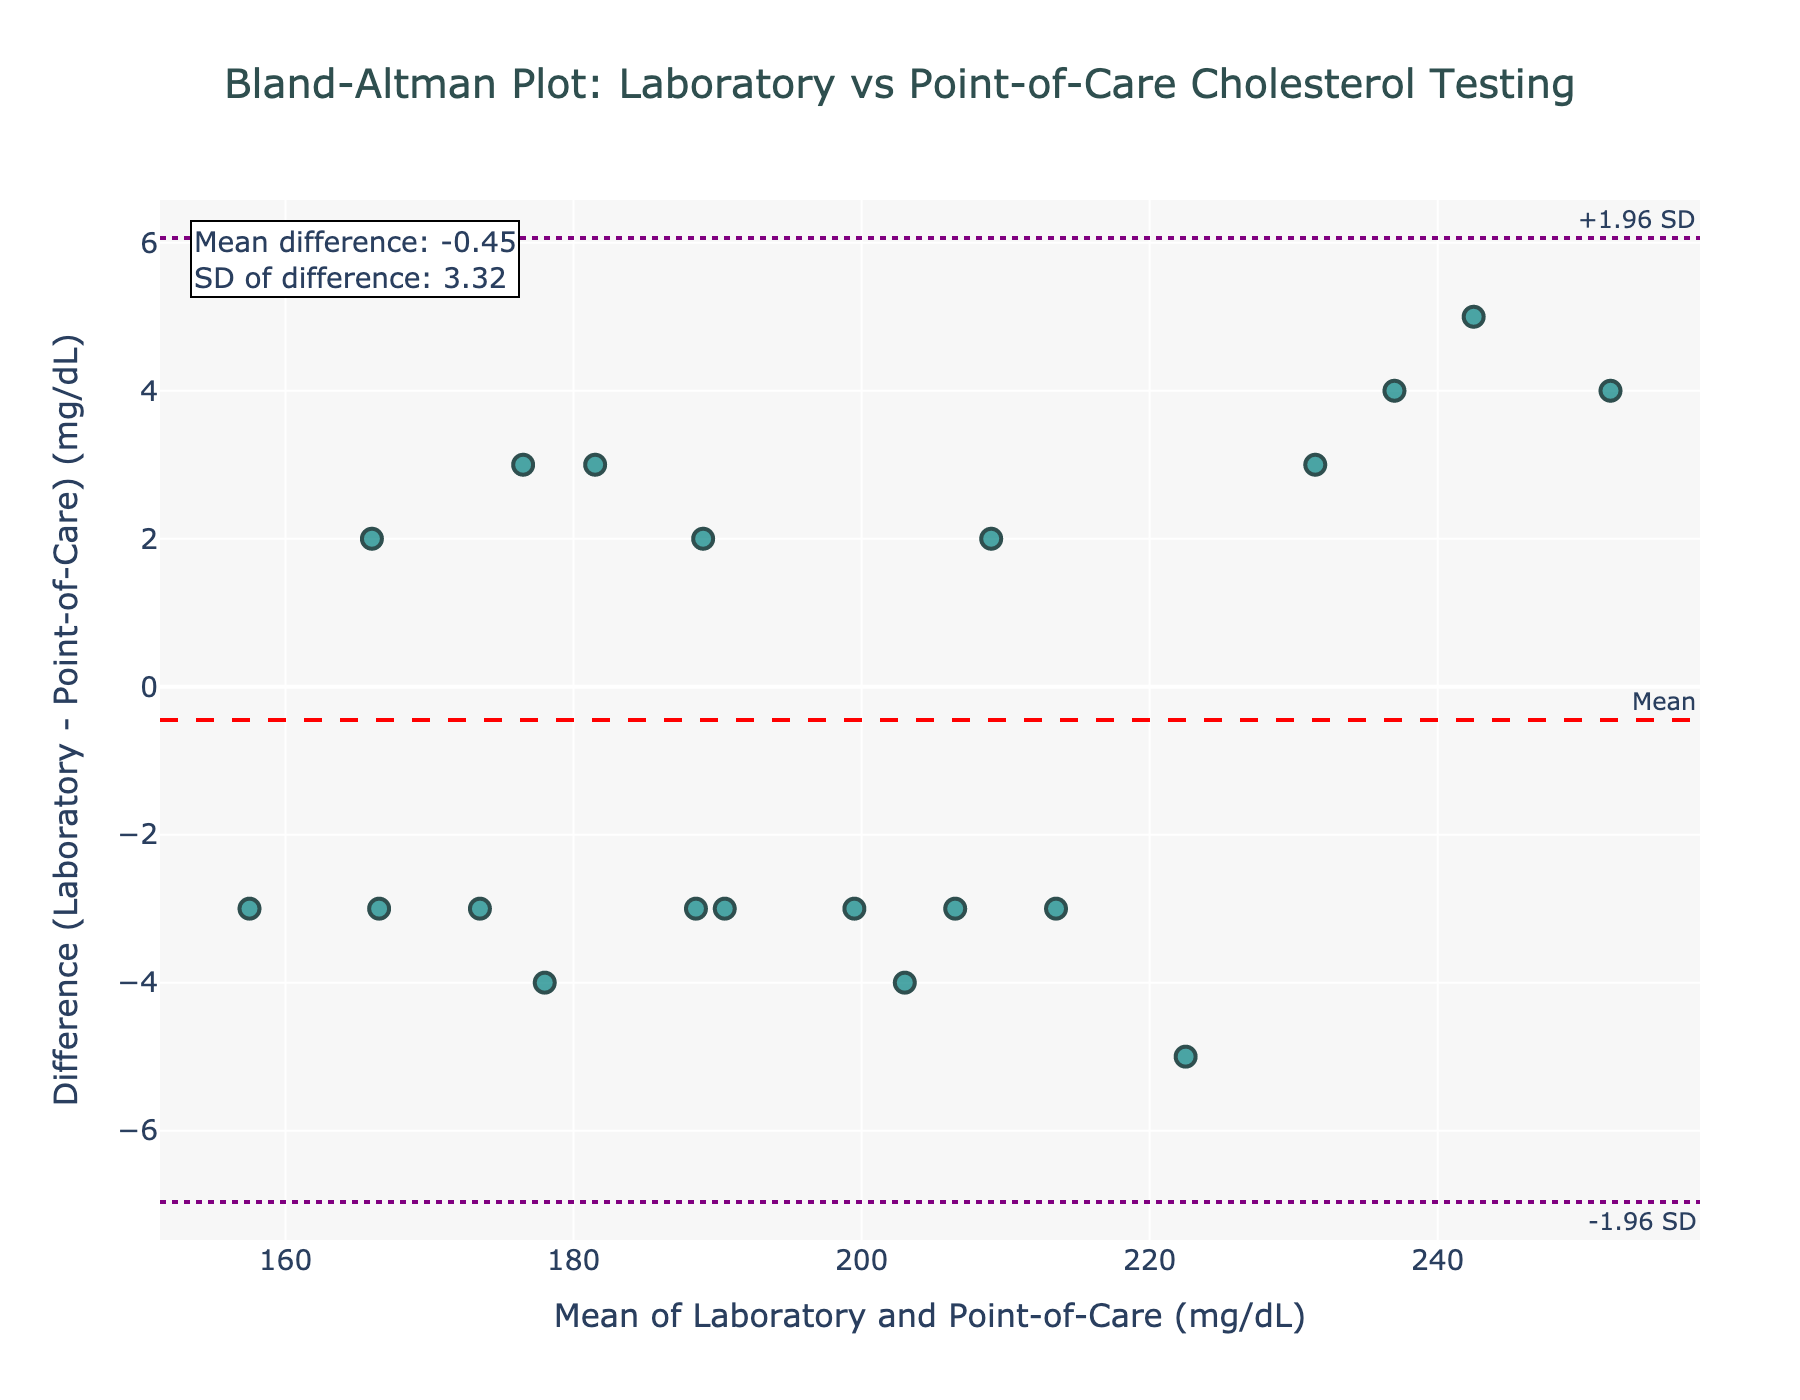How many data points are plotted on the figure? The data table provides 20 measurements (one per patient), and the plot should reflect all of these. Counting the plotted points confirms there are indeed 20 points.
Answer: 20 What is the title of the plot? The title is displayed at the top of the plot, and it reads: "Bland-Altman Plot: Laboratory vs Point-of-Care Cholesterol Testing".
Answer: Bland-Altman Plot: Laboratory vs Point-of-Care Cholesterol Testing What are the units used for the x-axis? The x-axis represents the mean of Laboratory and Point-of-Care values and is labeled, indicating the units as mg/dL (milligrams per deciliter).
Answer: mg/dL What is the mean difference value shown on the figure? The mean difference is the horizontal dashed red line annotated with "Mean". The text annotation in the figure confirms its value.
Answer: -0.60 What is the range between the upper and lower limits of agreement? The figure shows the upper and lower limits of agreement as dashed purple lines. To find the range, subtract the lower limit from the upper limit. Upper limit: 7.04 and lower limit: -8.24.
Answer: 15.28 Between which two values does the lower limit of agreement fall? The lower limit of agreement is the bottom dashed purple line, annotated as "-1.96 SD". The value is -8.24, and this falls between -10 and -5 on the y-axis.
Answer: -10 and -5 Are there any data points that fall outside the limits of agreement? To determine this, check if any points lie above the upper dashed purple line or below the lower dashed purple line. Count these points.
Answer: No What is the difference between the highest and lowest y-values in the plot? Identify the maximum and minimum y-values (differences) among the data points. The highest y-value is 10, and the lowest is -9. Subtract the minimum from the maximum.
Answer: 19 Which axis is labeled as "Difference (Laboratory - Point-of-Care) (mg/dL)"? The y-axis label is clearly visible on the left side of the plot, stating "Difference (Laboratory - Point-of-Care) (mg/dL)".
Answer: y-axis What is the standard deviation of the differences as shown on the figure? The standard deviation of the differences is provided in the text annotation in the top left corner. It states the SD value explicitly.
Answer: 4.39 